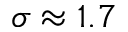Convert formula to latex. <formula><loc_0><loc_0><loc_500><loc_500>\sigma \approx 1 . 7</formula> 